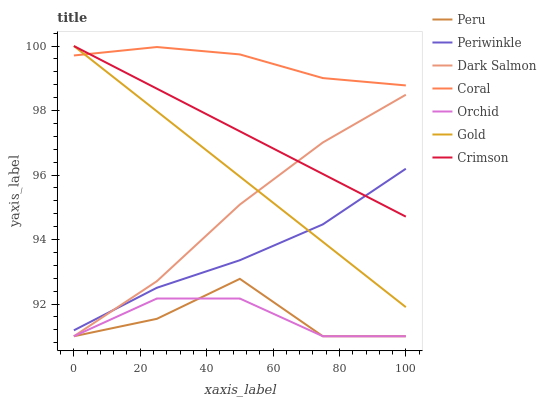Does Peru have the minimum area under the curve?
Answer yes or no. Yes. Does Coral have the maximum area under the curve?
Answer yes or no. Yes. Does Dark Salmon have the minimum area under the curve?
Answer yes or no. No. Does Dark Salmon have the maximum area under the curve?
Answer yes or no. No. Is Gold the smoothest?
Answer yes or no. Yes. Is Peru the roughest?
Answer yes or no. Yes. Is Coral the smoothest?
Answer yes or no. No. Is Coral the roughest?
Answer yes or no. No. Does Dark Salmon have the lowest value?
Answer yes or no. Yes. Does Coral have the lowest value?
Answer yes or no. No. Does Crimson have the highest value?
Answer yes or no. Yes. Does Coral have the highest value?
Answer yes or no. No. Is Orchid less than Gold?
Answer yes or no. Yes. Is Crimson greater than Peru?
Answer yes or no. Yes. Does Coral intersect Crimson?
Answer yes or no. Yes. Is Coral less than Crimson?
Answer yes or no. No. Is Coral greater than Crimson?
Answer yes or no. No. Does Orchid intersect Gold?
Answer yes or no. No. 